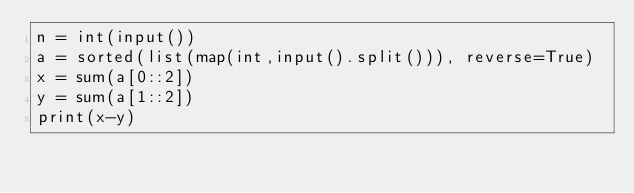<code> <loc_0><loc_0><loc_500><loc_500><_Python_>n = int(input())
a = sorted(list(map(int,input().split())), reverse=True)
x = sum(a[0::2])
y = sum(a[1::2])
print(x-y)
</code> 